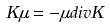Convert formula to latex. <formula><loc_0><loc_0><loc_500><loc_500>K \mu = - \mu d i v K</formula> 